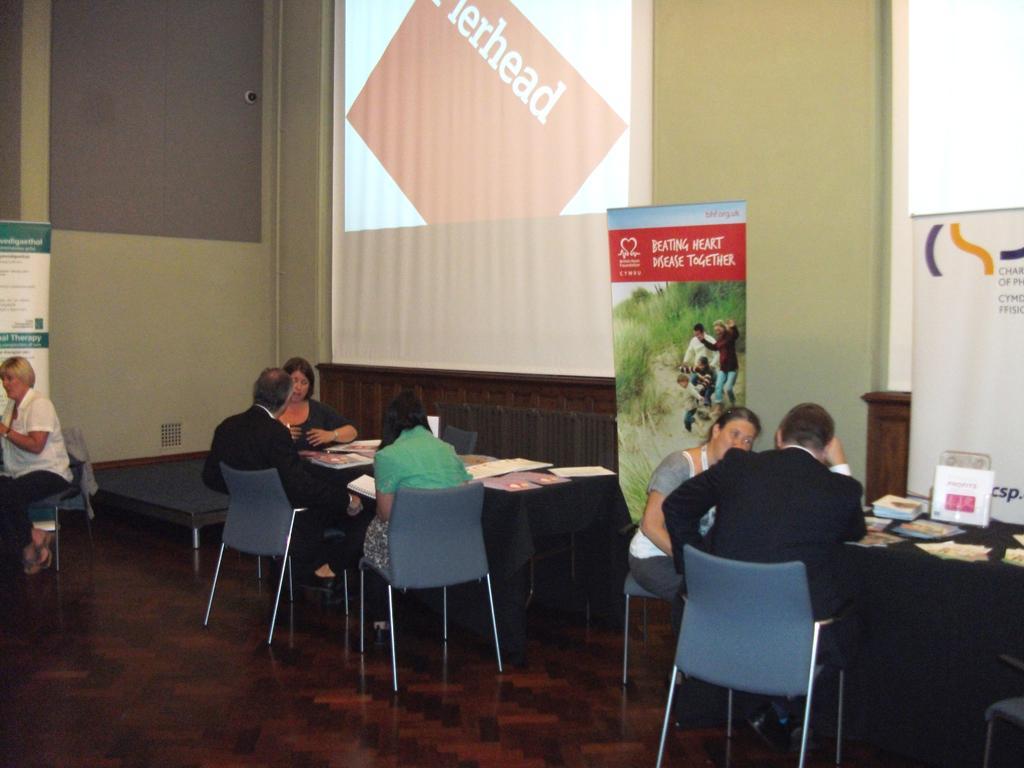Describe this image in one or two sentences. An indoor picture. This persons are sitting on chair. In-front of them there are tables, on tables there are papers. This are screens attached to a wall. This are banners. 